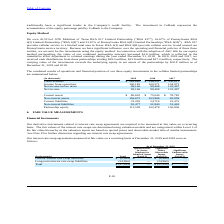According to Consolidated Communications Holdings's financial document, What is the company's ownership of GTE Mobilnet of Texas RSA#17? According to the financial document, 20.51%. The relevant text states: "We own 20.51%of GTE Mobilnet of Texas RSA #17 Limited Partnership (“RSA #17”), 16.67% of Pennsylvania RSA 6(I) Li..." Also, What was the cash distribution received in 2019 from partnerships? According to the financial document, $19.0 million. The relevant text states: "ash distributions from these partnerships totaling $19.0 million, $21.8 million and $17.2 million, respectively. The carrying value of the investments exceeds the u..." Also, What is the Total revenues for 2019? According to the financial document, $ 349,640 (in thousands). The relevant text states: "Total revenues $ 349,640 $ 346,251 $ 350,611..." Also, can you calculate: What was the increase / (decrease) in the total revenues from 2018 to 2019? Based on the calculation: 349,640 - 346,251, the result is 3389 (in thousands). This is based on the information: "Total revenues $ 349,640 $ 346,251 $ 350,611 Total revenues $ 349,640 $ 346,251 $ 350,611..." The key data points involved are: 346,251, 349,640. Also, can you calculate: What was the average income from operations for 2017-2019? To answer this question, I need to perform calculations using the financial data. The calculation is: (100,182 + 100,571 + 104,973) / 3, which equals 101908.67 (in thousands). This is based on the information: "Income from operations 100,182 100,571 104,973 Income from operations 100,182 100,571 104,973 Income from operations 100,182 100,571 104,973..." The key data points involved are: 100,182, 100,571, 104,973. Also, can you calculate: What was the percentage increase / (decrease) in the net income from 2018 to 2019? To answer this question, I need to perform calculations using the financial data. The calculation is: 99,146 / 99,408 - 1, which equals -0.26 (percentage). This is based on the information: "Net income before taxes 99,146 99,408 103,497 Net income before taxes 99,146 99,408 103,497..." The key data points involved are: 99,146, 99,408. 